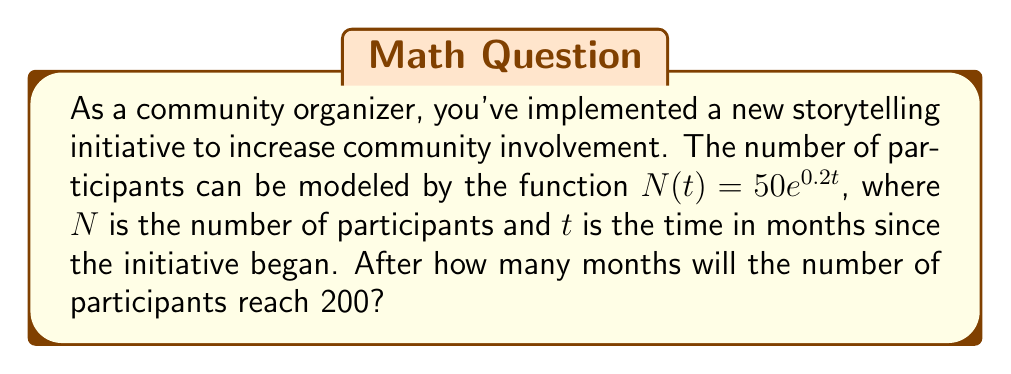Can you answer this question? Let's approach this step-by-step:

1) We are given the exponential function $N(t) = 50e^{0.2t}$, where:
   - $N(t)$ is the number of participants
   - 50 is the initial number of participants
   - $e$ is Euler's number (approximately 2.71828)
   - 0.2 is the growth rate
   - $t$ is the time in months

2) We want to find $t$ when $N(t) = 200$. So, let's set up the equation:

   $200 = 50e^{0.2t}$

3) Divide both sides by 50:

   $4 = e^{0.2t}$

4) Take the natural logarithm of both sides:

   $\ln(4) = \ln(e^{0.2t})$

5) Using the logarithm property $\ln(e^x) = x$, we get:

   $\ln(4) = 0.2t$

6) Solve for $t$:

   $t = \frac{\ln(4)}{0.2}$

7) Calculate the result:

   $t = \frac{\ln(4)}{0.2} \approx 6.93$

8) Since we're dealing with months, we need to round up to the nearest whole month.
Answer: 7 months 